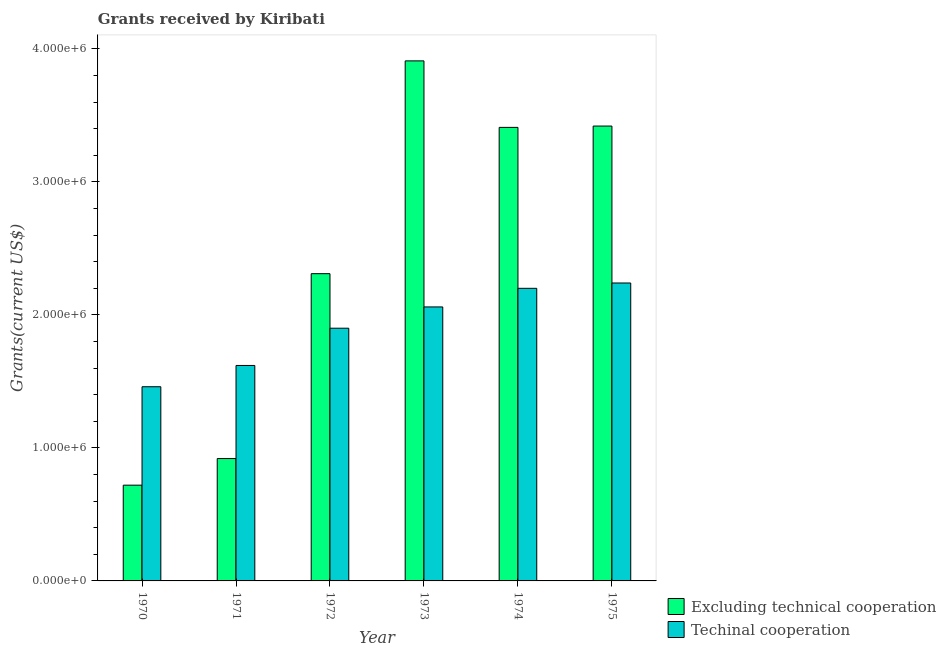How many different coloured bars are there?
Offer a terse response. 2. Are the number of bars on each tick of the X-axis equal?
Offer a terse response. Yes. What is the label of the 5th group of bars from the left?
Your answer should be very brief. 1974. In how many cases, is the number of bars for a given year not equal to the number of legend labels?
Provide a short and direct response. 0. What is the amount of grants received(including technical cooperation) in 1975?
Offer a very short reply. 2.24e+06. Across all years, what is the maximum amount of grants received(including technical cooperation)?
Provide a short and direct response. 2.24e+06. Across all years, what is the minimum amount of grants received(excluding technical cooperation)?
Offer a terse response. 7.20e+05. In which year was the amount of grants received(including technical cooperation) maximum?
Your answer should be very brief. 1975. What is the total amount of grants received(including technical cooperation) in the graph?
Offer a very short reply. 1.15e+07. What is the difference between the amount of grants received(excluding technical cooperation) in 1973 and that in 1974?
Your response must be concise. 5.00e+05. What is the difference between the amount of grants received(excluding technical cooperation) in 1972 and the amount of grants received(including technical cooperation) in 1974?
Your answer should be compact. -1.10e+06. What is the average amount of grants received(including technical cooperation) per year?
Provide a succinct answer. 1.91e+06. In how many years, is the amount of grants received(excluding technical cooperation) greater than 2400000 US$?
Ensure brevity in your answer.  3. What is the ratio of the amount of grants received(excluding technical cooperation) in 1971 to that in 1972?
Provide a short and direct response. 0.4. Is the amount of grants received(including technical cooperation) in 1970 less than that in 1974?
Your answer should be compact. Yes. What is the difference between the highest and the lowest amount of grants received(excluding technical cooperation)?
Make the answer very short. 3.19e+06. Is the sum of the amount of grants received(excluding technical cooperation) in 1972 and 1973 greater than the maximum amount of grants received(including technical cooperation) across all years?
Offer a very short reply. Yes. What does the 1st bar from the left in 1974 represents?
Ensure brevity in your answer.  Excluding technical cooperation. What does the 2nd bar from the right in 1975 represents?
Offer a terse response. Excluding technical cooperation. Are all the bars in the graph horizontal?
Ensure brevity in your answer.  No. How many years are there in the graph?
Offer a terse response. 6. What is the difference between two consecutive major ticks on the Y-axis?
Provide a short and direct response. 1.00e+06. Does the graph contain any zero values?
Keep it short and to the point. No. How many legend labels are there?
Offer a very short reply. 2. What is the title of the graph?
Keep it short and to the point. Grants received by Kiribati. Does "Education" appear as one of the legend labels in the graph?
Give a very brief answer. No. What is the label or title of the X-axis?
Your answer should be very brief. Year. What is the label or title of the Y-axis?
Your answer should be very brief. Grants(current US$). What is the Grants(current US$) in Excluding technical cooperation in 1970?
Offer a terse response. 7.20e+05. What is the Grants(current US$) of Techinal cooperation in 1970?
Offer a very short reply. 1.46e+06. What is the Grants(current US$) in Excluding technical cooperation in 1971?
Offer a very short reply. 9.20e+05. What is the Grants(current US$) of Techinal cooperation in 1971?
Provide a short and direct response. 1.62e+06. What is the Grants(current US$) in Excluding technical cooperation in 1972?
Offer a terse response. 2.31e+06. What is the Grants(current US$) of Techinal cooperation in 1972?
Provide a short and direct response. 1.90e+06. What is the Grants(current US$) in Excluding technical cooperation in 1973?
Offer a very short reply. 3.91e+06. What is the Grants(current US$) of Techinal cooperation in 1973?
Your response must be concise. 2.06e+06. What is the Grants(current US$) of Excluding technical cooperation in 1974?
Give a very brief answer. 3.41e+06. What is the Grants(current US$) of Techinal cooperation in 1974?
Provide a short and direct response. 2.20e+06. What is the Grants(current US$) of Excluding technical cooperation in 1975?
Your answer should be very brief. 3.42e+06. What is the Grants(current US$) in Techinal cooperation in 1975?
Make the answer very short. 2.24e+06. Across all years, what is the maximum Grants(current US$) of Excluding technical cooperation?
Ensure brevity in your answer.  3.91e+06. Across all years, what is the maximum Grants(current US$) of Techinal cooperation?
Provide a short and direct response. 2.24e+06. Across all years, what is the minimum Grants(current US$) in Excluding technical cooperation?
Offer a terse response. 7.20e+05. Across all years, what is the minimum Grants(current US$) in Techinal cooperation?
Provide a short and direct response. 1.46e+06. What is the total Grants(current US$) in Excluding technical cooperation in the graph?
Your answer should be very brief. 1.47e+07. What is the total Grants(current US$) of Techinal cooperation in the graph?
Keep it short and to the point. 1.15e+07. What is the difference between the Grants(current US$) of Excluding technical cooperation in 1970 and that in 1971?
Offer a very short reply. -2.00e+05. What is the difference between the Grants(current US$) in Excluding technical cooperation in 1970 and that in 1972?
Keep it short and to the point. -1.59e+06. What is the difference between the Grants(current US$) of Techinal cooperation in 1970 and that in 1972?
Provide a succinct answer. -4.40e+05. What is the difference between the Grants(current US$) of Excluding technical cooperation in 1970 and that in 1973?
Keep it short and to the point. -3.19e+06. What is the difference between the Grants(current US$) in Techinal cooperation in 1970 and that in 1973?
Your response must be concise. -6.00e+05. What is the difference between the Grants(current US$) in Excluding technical cooperation in 1970 and that in 1974?
Ensure brevity in your answer.  -2.69e+06. What is the difference between the Grants(current US$) in Techinal cooperation in 1970 and that in 1974?
Offer a very short reply. -7.40e+05. What is the difference between the Grants(current US$) of Excluding technical cooperation in 1970 and that in 1975?
Your answer should be very brief. -2.70e+06. What is the difference between the Grants(current US$) in Techinal cooperation in 1970 and that in 1975?
Your answer should be compact. -7.80e+05. What is the difference between the Grants(current US$) of Excluding technical cooperation in 1971 and that in 1972?
Keep it short and to the point. -1.39e+06. What is the difference between the Grants(current US$) in Techinal cooperation in 1971 and that in 1972?
Your answer should be compact. -2.80e+05. What is the difference between the Grants(current US$) of Excluding technical cooperation in 1971 and that in 1973?
Ensure brevity in your answer.  -2.99e+06. What is the difference between the Grants(current US$) in Techinal cooperation in 1971 and that in 1973?
Offer a very short reply. -4.40e+05. What is the difference between the Grants(current US$) of Excluding technical cooperation in 1971 and that in 1974?
Ensure brevity in your answer.  -2.49e+06. What is the difference between the Grants(current US$) in Techinal cooperation in 1971 and that in 1974?
Keep it short and to the point. -5.80e+05. What is the difference between the Grants(current US$) of Excluding technical cooperation in 1971 and that in 1975?
Give a very brief answer. -2.50e+06. What is the difference between the Grants(current US$) of Techinal cooperation in 1971 and that in 1975?
Ensure brevity in your answer.  -6.20e+05. What is the difference between the Grants(current US$) in Excluding technical cooperation in 1972 and that in 1973?
Offer a terse response. -1.60e+06. What is the difference between the Grants(current US$) in Excluding technical cooperation in 1972 and that in 1974?
Make the answer very short. -1.10e+06. What is the difference between the Grants(current US$) of Techinal cooperation in 1972 and that in 1974?
Ensure brevity in your answer.  -3.00e+05. What is the difference between the Grants(current US$) in Excluding technical cooperation in 1972 and that in 1975?
Keep it short and to the point. -1.11e+06. What is the difference between the Grants(current US$) of Techinal cooperation in 1972 and that in 1975?
Give a very brief answer. -3.40e+05. What is the difference between the Grants(current US$) in Excluding technical cooperation in 1973 and that in 1974?
Make the answer very short. 5.00e+05. What is the difference between the Grants(current US$) of Techinal cooperation in 1973 and that in 1974?
Your answer should be compact. -1.40e+05. What is the difference between the Grants(current US$) in Excluding technical cooperation in 1973 and that in 1975?
Make the answer very short. 4.90e+05. What is the difference between the Grants(current US$) of Techinal cooperation in 1974 and that in 1975?
Your response must be concise. -4.00e+04. What is the difference between the Grants(current US$) of Excluding technical cooperation in 1970 and the Grants(current US$) of Techinal cooperation in 1971?
Provide a succinct answer. -9.00e+05. What is the difference between the Grants(current US$) of Excluding technical cooperation in 1970 and the Grants(current US$) of Techinal cooperation in 1972?
Make the answer very short. -1.18e+06. What is the difference between the Grants(current US$) in Excluding technical cooperation in 1970 and the Grants(current US$) in Techinal cooperation in 1973?
Keep it short and to the point. -1.34e+06. What is the difference between the Grants(current US$) in Excluding technical cooperation in 1970 and the Grants(current US$) in Techinal cooperation in 1974?
Your answer should be compact. -1.48e+06. What is the difference between the Grants(current US$) in Excluding technical cooperation in 1970 and the Grants(current US$) in Techinal cooperation in 1975?
Provide a short and direct response. -1.52e+06. What is the difference between the Grants(current US$) of Excluding technical cooperation in 1971 and the Grants(current US$) of Techinal cooperation in 1972?
Offer a very short reply. -9.80e+05. What is the difference between the Grants(current US$) of Excluding technical cooperation in 1971 and the Grants(current US$) of Techinal cooperation in 1973?
Your answer should be very brief. -1.14e+06. What is the difference between the Grants(current US$) in Excluding technical cooperation in 1971 and the Grants(current US$) in Techinal cooperation in 1974?
Ensure brevity in your answer.  -1.28e+06. What is the difference between the Grants(current US$) of Excluding technical cooperation in 1971 and the Grants(current US$) of Techinal cooperation in 1975?
Give a very brief answer. -1.32e+06. What is the difference between the Grants(current US$) of Excluding technical cooperation in 1972 and the Grants(current US$) of Techinal cooperation in 1975?
Make the answer very short. 7.00e+04. What is the difference between the Grants(current US$) in Excluding technical cooperation in 1973 and the Grants(current US$) in Techinal cooperation in 1974?
Your response must be concise. 1.71e+06. What is the difference between the Grants(current US$) in Excluding technical cooperation in 1973 and the Grants(current US$) in Techinal cooperation in 1975?
Ensure brevity in your answer.  1.67e+06. What is the difference between the Grants(current US$) in Excluding technical cooperation in 1974 and the Grants(current US$) in Techinal cooperation in 1975?
Offer a terse response. 1.17e+06. What is the average Grants(current US$) of Excluding technical cooperation per year?
Keep it short and to the point. 2.45e+06. What is the average Grants(current US$) in Techinal cooperation per year?
Ensure brevity in your answer.  1.91e+06. In the year 1970, what is the difference between the Grants(current US$) in Excluding technical cooperation and Grants(current US$) in Techinal cooperation?
Your answer should be very brief. -7.40e+05. In the year 1971, what is the difference between the Grants(current US$) in Excluding technical cooperation and Grants(current US$) in Techinal cooperation?
Offer a terse response. -7.00e+05. In the year 1973, what is the difference between the Grants(current US$) in Excluding technical cooperation and Grants(current US$) in Techinal cooperation?
Ensure brevity in your answer.  1.85e+06. In the year 1974, what is the difference between the Grants(current US$) in Excluding technical cooperation and Grants(current US$) in Techinal cooperation?
Make the answer very short. 1.21e+06. In the year 1975, what is the difference between the Grants(current US$) in Excluding technical cooperation and Grants(current US$) in Techinal cooperation?
Your answer should be very brief. 1.18e+06. What is the ratio of the Grants(current US$) of Excluding technical cooperation in 1970 to that in 1971?
Offer a terse response. 0.78. What is the ratio of the Grants(current US$) in Techinal cooperation in 1970 to that in 1971?
Provide a short and direct response. 0.9. What is the ratio of the Grants(current US$) of Excluding technical cooperation in 1970 to that in 1972?
Keep it short and to the point. 0.31. What is the ratio of the Grants(current US$) of Techinal cooperation in 1970 to that in 1972?
Your answer should be very brief. 0.77. What is the ratio of the Grants(current US$) in Excluding technical cooperation in 1970 to that in 1973?
Give a very brief answer. 0.18. What is the ratio of the Grants(current US$) of Techinal cooperation in 1970 to that in 1973?
Provide a succinct answer. 0.71. What is the ratio of the Grants(current US$) of Excluding technical cooperation in 1970 to that in 1974?
Offer a very short reply. 0.21. What is the ratio of the Grants(current US$) in Techinal cooperation in 1970 to that in 1974?
Provide a succinct answer. 0.66. What is the ratio of the Grants(current US$) in Excluding technical cooperation in 1970 to that in 1975?
Offer a very short reply. 0.21. What is the ratio of the Grants(current US$) in Techinal cooperation in 1970 to that in 1975?
Keep it short and to the point. 0.65. What is the ratio of the Grants(current US$) of Excluding technical cooperation in 1971 to that in 1972?
Offer a terse response. 0.4. What is the ratio of the Grants(current US$) of Techinal cooperation in 1971 to that in 1972?
Offer a very short reply. 0.85. What is the ratio of the Grants(current US$) in Excluding technical cooperation in 1971 to that in 1973?
Your answer should be compact. 0.24. What is the ratio of the Grants(current US$) of Techinal cooperation in 1971 to that in 1973?
Ensure brevity in your answer.  0.79. What is the ratio of the Grants(current US$) of Excluding technical cooperation in 1971 to that in 1974?
Offer a terse response. 0.27. What is the ratio of the Grants(current US$) of Techinal cooperation in 1971 to that in 1974?
Keep it short and to the point. 0.74. What is the ratio of the Grants(current US$) in Excluding technical cooperation in 1971 to that in 1975?
Give a very brief answer. 0.27. What is the ratio of the Grants(current US$) in Techinal cooperation in 1971 to that in 1975?
Provide a short and direct response. 0.72. What is the ratio of the Grants(current US$) of Excluding technical cooperation in 1972 to that in 1973?
Offer a very short reply. 0.59. What is the ratio of the Grants(current US$) in Techinal cooperation in 1972 to that in 1973?
Provide a succinct answer. 0.92. What is the ratio of the Grants(current US$) in Excluding technical cooperation in 1972 to that in 1974?
Give a very brief answer. 0.68. What is the ratio of the Grants(current US$) of Techinal cooperation in 1972 to that in 1974?
Ensure brevity in your answer.  0.86. What is the ratio of the Grants(current US$) in Excluding technical cooperation in 1972 to that in 1975?
Your answer should be compact. 0.68. What is the ratio of the Grants(current US$) in Techinal cooperation in 1972 to that in 1975?
Provide a short and direct response. 0.85. What is the ratio of the Grants(current US$) in Excluding technical cooperation in 1973 to that in 1974?
Offer a terse response. 1.15. What is the ratio of the Grants(current US$) in Techinal cooperation in 1973 to that in 1974?
Offer a very short reply. 0.94. What is the ratio of the Grants(current US$) of Excluding technical cooperation in 1973 to that in 1975?
Keep it short and to the point. 1.14. What is the ratio of the Grants(current US$) of Techinal cooperation in 1973 to that in 1975?
Offer a very short reply. 0.92. What is the ratio of the Grants(current US$) of Excluding technical cooperation in 1974 to that in 1975?
Your answer should be compact. 1. What is the ratio of the Grants(current US$) in Techinal cooperation in 1974 to that in 1975?
Your answer should be compact. 0.98. What is the difference between the highest and the second highest Grants(current US$) in Techinal cooperation?
Your answer should be very brief. 4.00e+04. What is the difference between the highest and the lowest Grants(current US$) in Excluding technical cooperation?
Provide a succinct answer. 3.19e+06. What is the difference between the highest and the lowest Grants(current US$) in Techinal cooperation?
Your answer should be compact. 7.80e+05. 